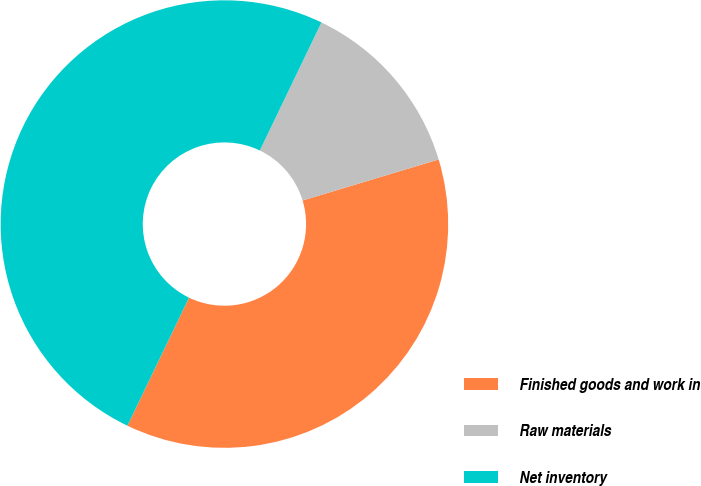Convert chart. <chart><loc_0><loc_0><loc_500><loc_500><pie_chart><fcel>Finished goods and work in<fcel>Raw materials<fcel>Net inventory<nl><fcel>36.8%<fcel>13.2%<fcel>50.0%<nl></chart> 